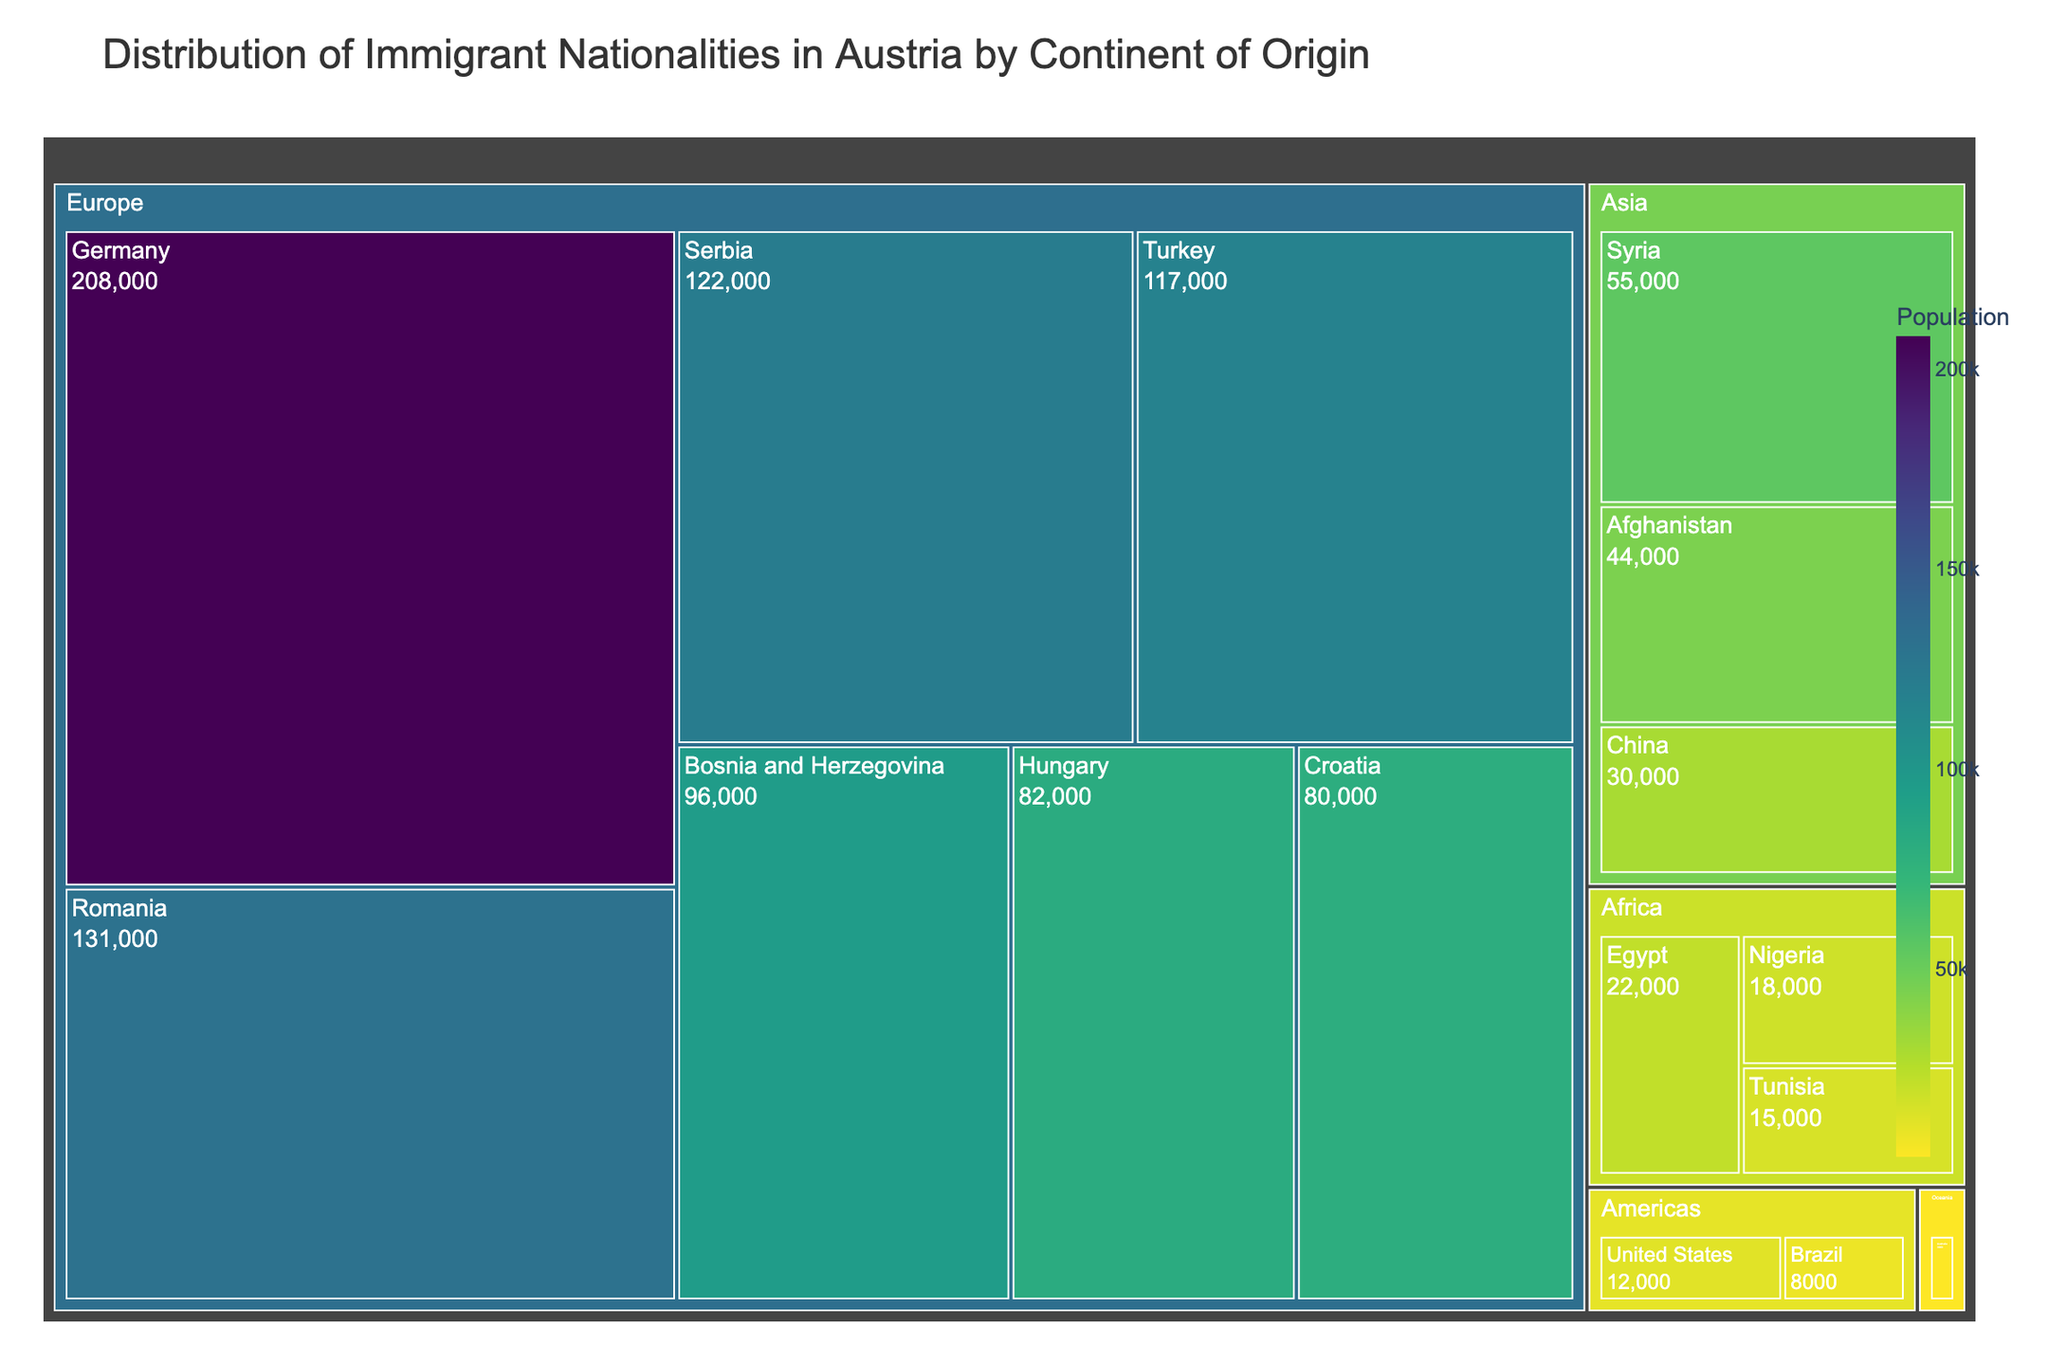What is the title of the figure? The title is usually prominently displayed at the top of the figure. In this case, it is explicitly defined in the code where `title='Distribution of Immigrant Nationalities in Austria by Continent of Origin'`.
Answer: Distribution of Immigrant Nationalities in Austria by Continent of Origin Which country has the largest immigrant population in Austria? By looking at the size of the boxes in the treemap, the largest box indicates the country with the highest population. In this case, Germany has the largest box on the Europe continent.
Answer: Germany How many continents are represented in the figure? The continents are the top-level categories in the treemap, represented by different groups of color-coded boxes. From the data, the continents listed are Europe, Asia, Africa, Americas, and Oceania.
Answer: 5 What is the total immigrant population from Africa? To get the total immigrant population from Africa, sum up the populations of all African countries listed: Egypt (22,000), Nigeria (18,000), and Tunisia (15,000). The total is 22,000 + 18,000 + 15,000 = 55,000.
Answer: 55,000 Compare the immigrant populations of Turkey and Hungary. Which one has a higher population? Find the boxes representing Turkey and Hungary in the Europe continent. The population for Turkey is 117,000 and for Hungary is 82,000. Turkey has a higher population than Hungary.
Answer: Turkey What is the smallest immigrant population shown in the figure, and which country does it represent? The smallest population corresponds to the smallest box in the treemap. By scanning the figure, the smallest box belongs to Australia with a population of 3,000.
Answer: Australia, 3,000 How does the population of immigrants from Syria compare to that from Afghanistan? Both Syria and Afghanistan are in the Asia continent. The population for Syria is 55,000 and for Afghanistan is 44,000. Syria has a larger immigrant population than Afghanistan.
Answer: Syria What percentage of European immigrants does Romania represent? The total European immigrant population can be computed by summing up all European countries' populations. The specific population for Romania is 131,000. The total European population is 208,000 + 131,000 + 122,000 + 117,000 + 96,000 + 82,000 + 80,000 = 836,000. The percentage is (131,000 / 836,000) * 100 = 15.67%.
Answer: 15.67% Which continent has the highest diversity of represented countries? The continent with the highest number of boxes (countries) in the treemap indicates the highest diversity. Europe has the most boxes as it includes Germany, Romania, Serbia, Turkey, Bosnia and Herzegovina, Hungary, and Croatia.
Answer: Europe If you combine the immigrant populations from the Americas and Oceania, what would be their total? Sum up the populations from the countries in the Americas and Oceania. United States (12,000), Brazil (8,000) from the Americas, and Australia (3,000) from Oceania. Total is 12,000 + 8,000 + 3,000 = 23,000.
Answer: 23,000 